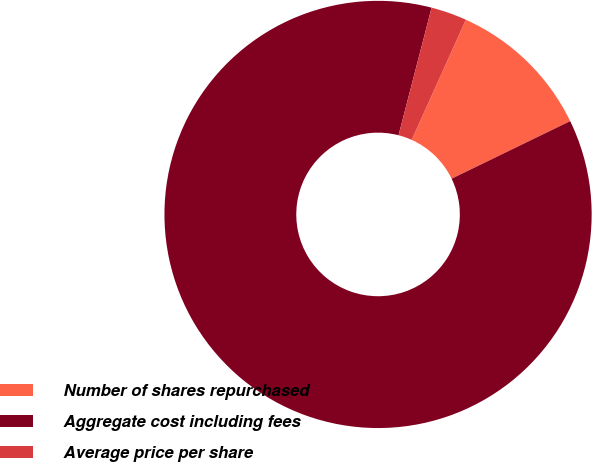<chart> <loc_0><loc_0><loc_500><loc_500><pie_chart><fcel>Number of shares repurchased<fcel>Aggregate cost including fees<fcel>Average price per share<nl><fcel>11.06%<fcel>86.22%<fcel>2.71%<nl></chart> 